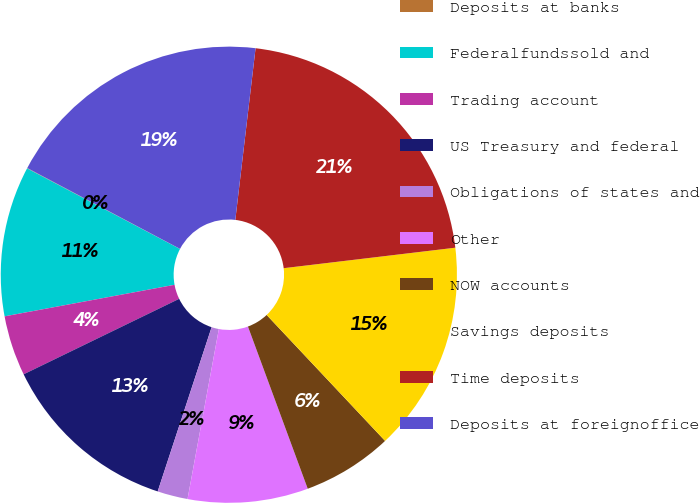Convert chart. <chart><loc_0><loc_0><loc_500><loc_500><pie_chart><fcel>Deposits at banks<fcel>Federalfundssold and<fcel>Trading account<fcel>US Treasury and federal<fcel>Obligations of states and<fcel>Other<fcel>NOW accounts<fcel>Savings deposits<fcel>Time deposits<fcel>Deposits at foreignoffice<nl><fcel>0.03%<fcel>10.64%<fcel>4.27%<fcel>12.76%<fcel>2.15%<fcel>8.52%<fcel>6.39%<fcel>14.88%<fcel>21.24%<fcel>19.12%<nl></chart> 